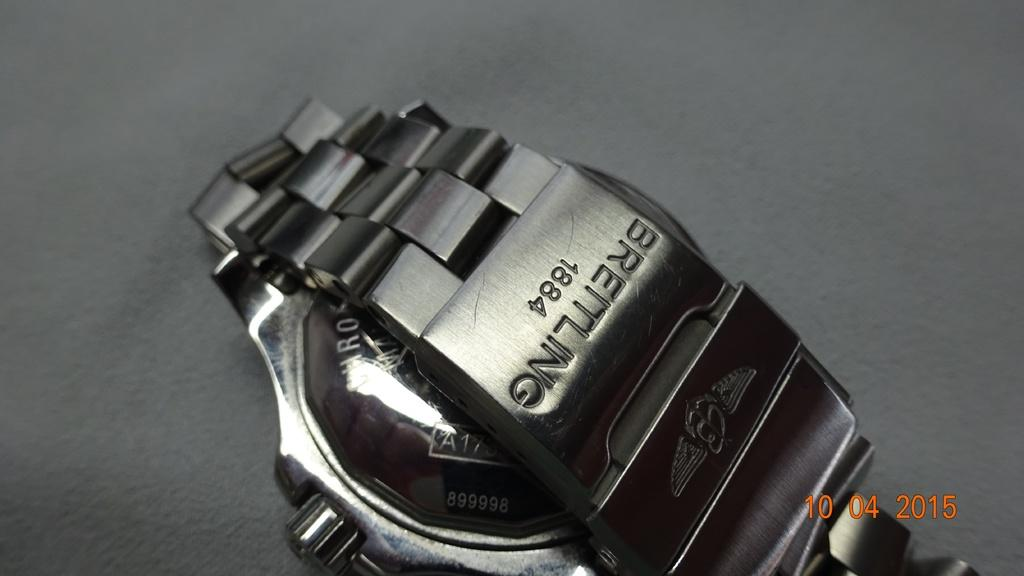Provide a one-sentence caption for the provided image. A Breitling dark silver wrist watch turned over on his face. 